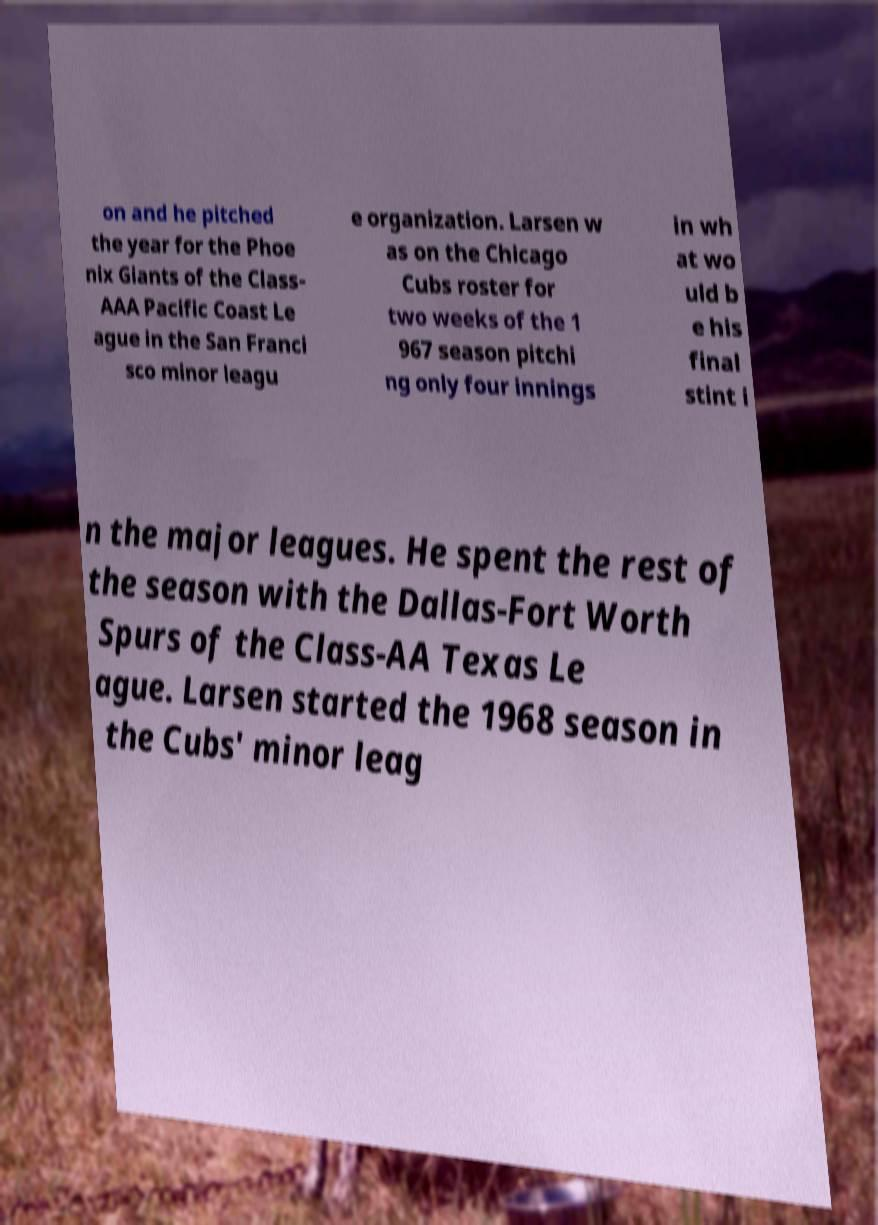What messages or text are displayed in this image? I need them in a readable, typed format. on and he pitched the year for the Phoe nix Giants of the Class- AAA Pacific Coast Le ague in the San Franci sco minor leagu e organization. Larsen w as on the Chicago Cubs roster for two weeks of the 1 967 season pitchi ng only four innings in wh at wo uld b e his final stint i n the major leagues. He spent the rest of the season with the Dallas-Fort Worth Spurs of the Class-AA Texas Le ague. Larsen started the 1968 season in the Cubs' minor leag 